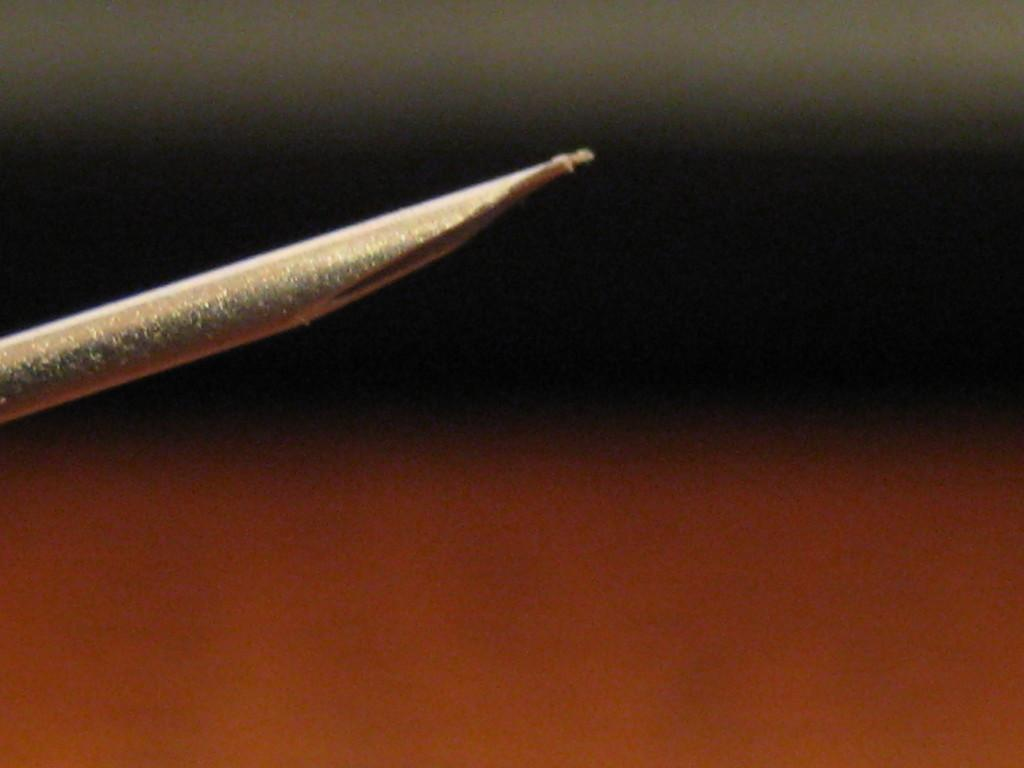What object in the image resembles a straw? There is an object in the image that resembles a straw. Can you describe the background of the image? The background of the image has three distinct colors, forming a tricolor pattern. What season is depicted in the image? The image does not depict a specific season; it only shows a tricolor pattern in the background. 